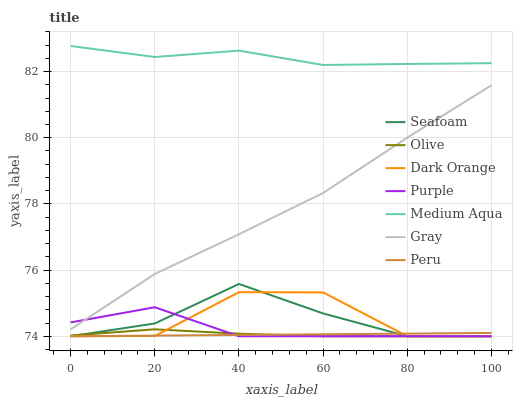Does Gray have the minimum area under the curve?
Answer yes or no. No. Does Gray have the maximum area under the curve?
Answer yes or no. No. Is Gray the smoothest?
Answer yes or no. No. Is Gray the roughest?
Answer yes or no. No. Does Gray have the lowest value?
Answer yes or no. No. Does Gray have the highest value?
Answer yes or no. No. Is Olive less than Gray?
Answer yes or no. Yes. Is Medium Aqua greater than Dark Orange?
Answer yes or no. Yes. Does Olive intersect Gray?
Answer yes or no. No. 